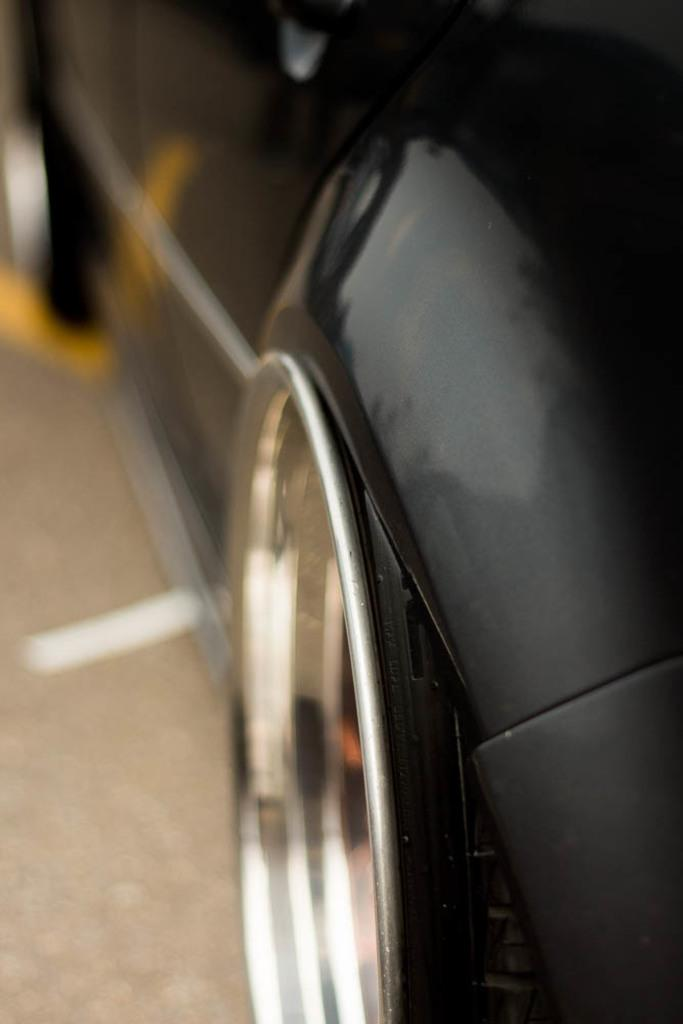What type of vehicle is in the image? There is a black car in the image. What is the car doing in the image? The car is moving on the road. Can you describe the visual quality of the right side of the image? The right side of the image is blurred. What type of apple is being eaten by the person in the car? There is no person or apple visible in the image; it only shows a black car moving on the road. Can you hear the mountain crying in the background of the image? There is no mountain or sound in the image; it only shows a black car moving on the road. 